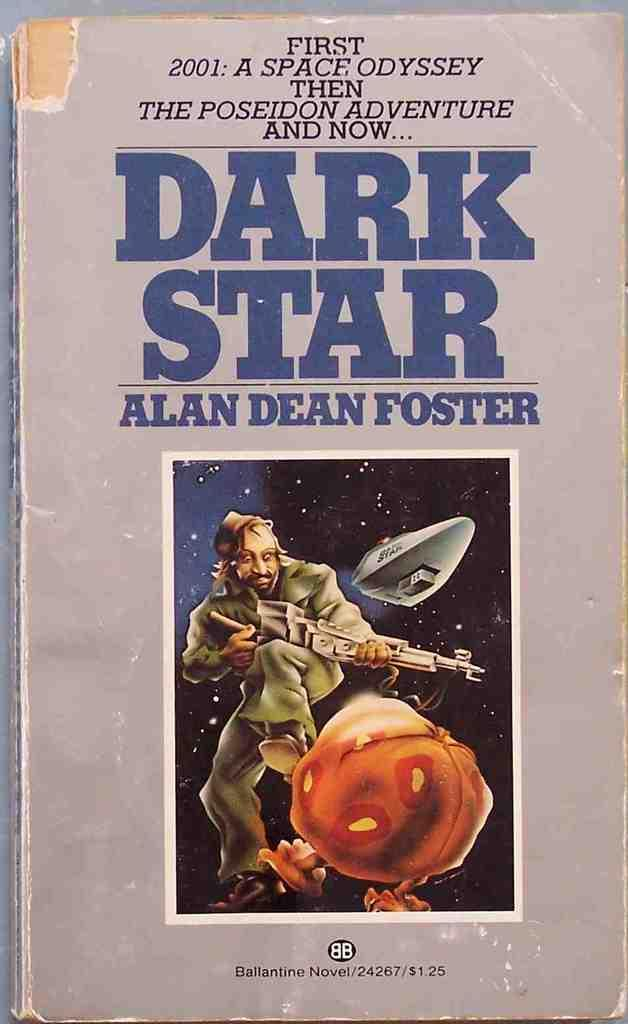<image>
Write a terse but informative summary of the picture. An drawing is included on the cover of the book Dark Star which has an edge missing. 